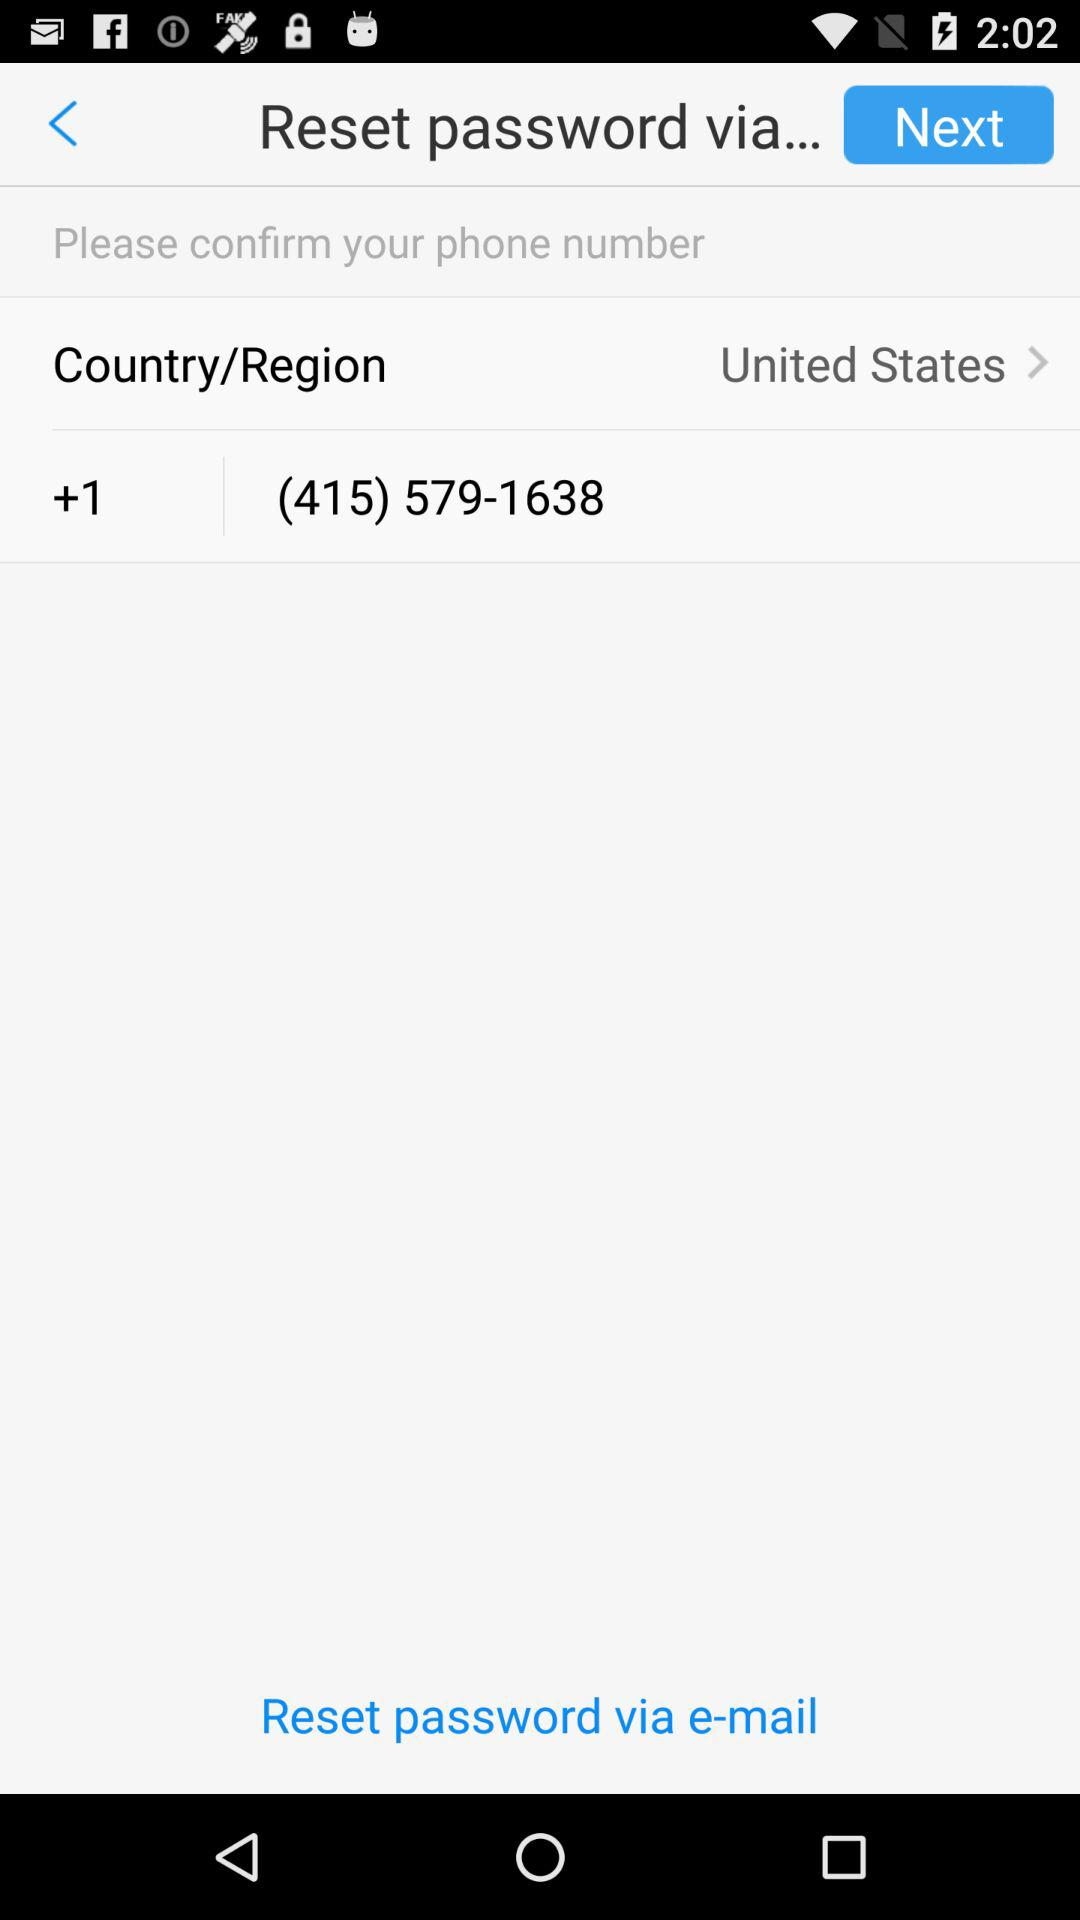What is the phone number? The phone number is (415) 579-1638. 